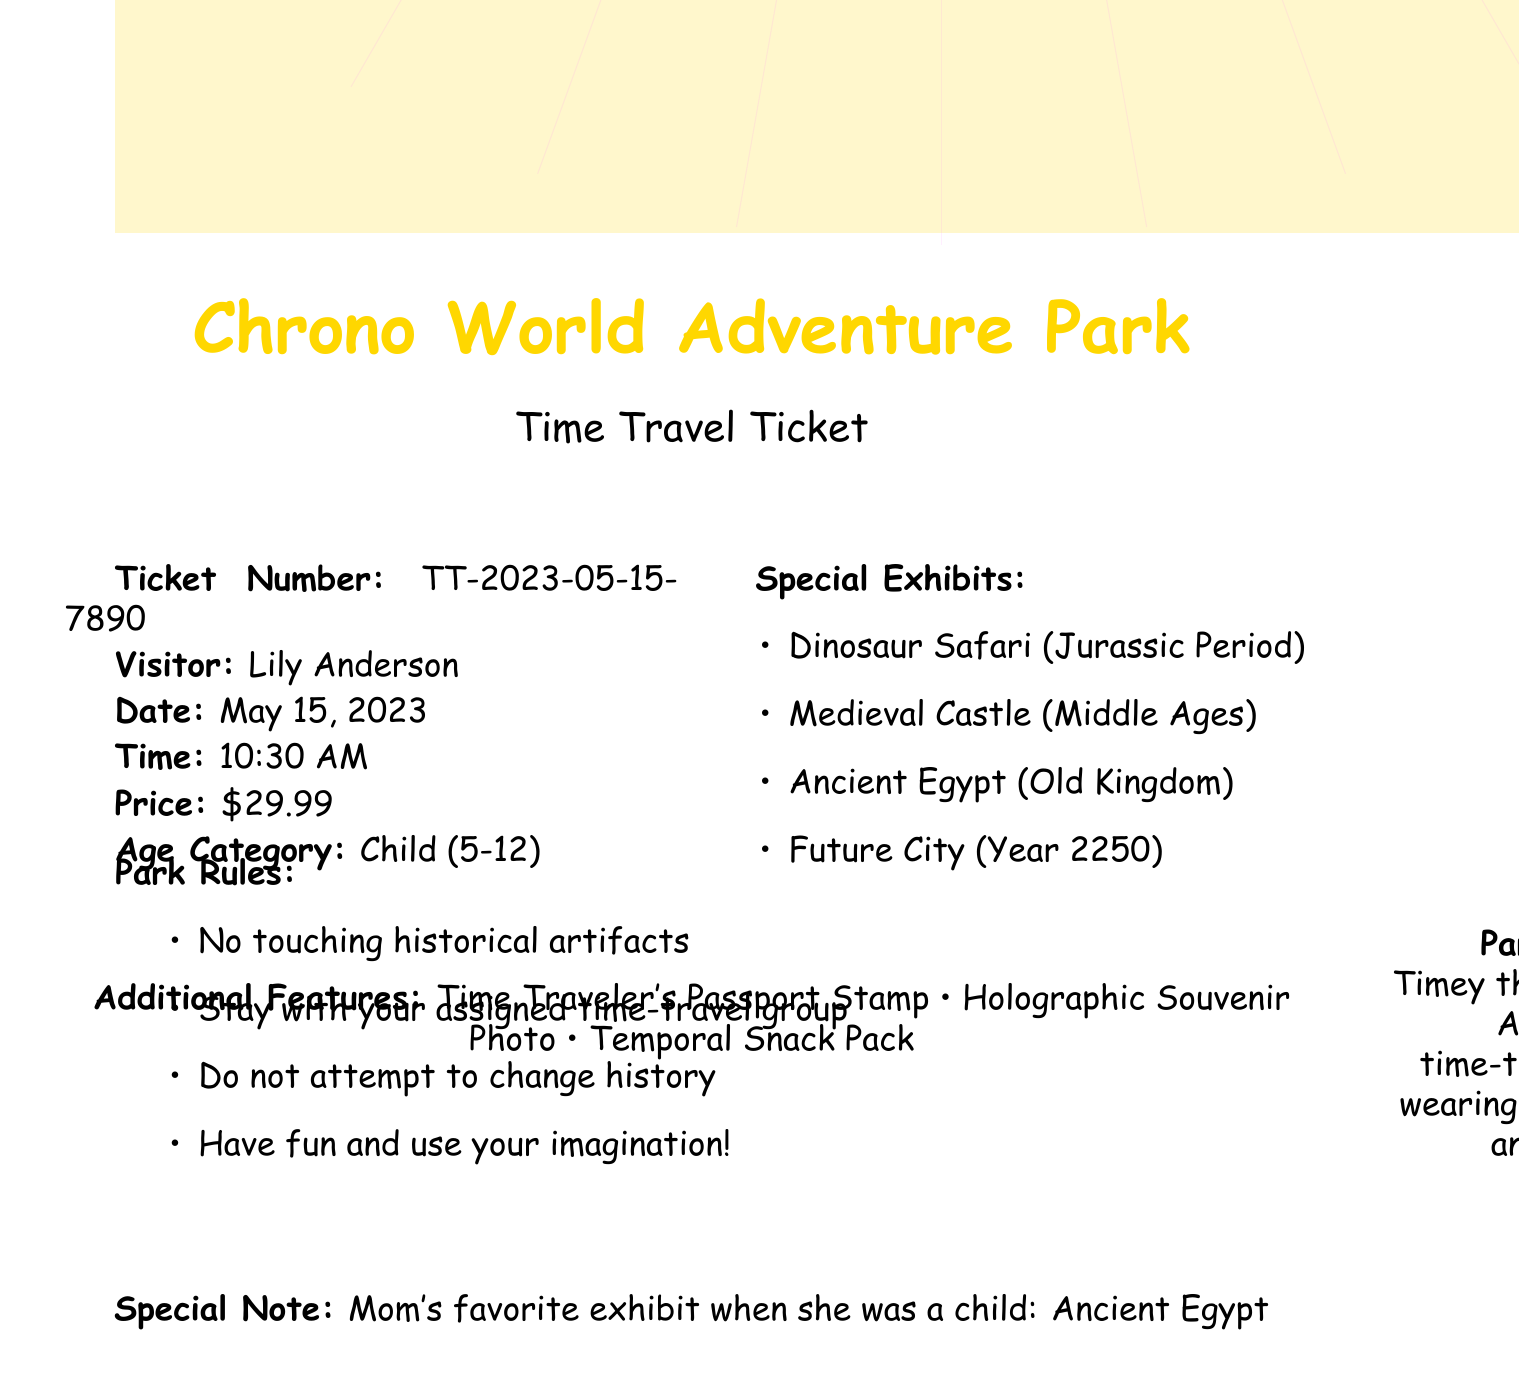What is the name of the park? The park name is provided at the beginning of the document.
Answer: Chrono World Adventure Park What is the ticket number? The ticket number is mentioned under the ticket details section of the document.
Answer: TT-2023-05-15-7890 What is the admission price? The price is listed clearly in the ticket details section.
Answer: $29.99 Who is the visitor? The visitor's name is specified in the ticket details.
Answer: Lily Anderson Which special exhibit was Mom's favorite when she was a child? This information can be found in the special note at the bottom of the document.
Answer: Ancient Egypt What age category does this ticket apply to? The age category is listed within the ticket details section.
Answer: Child (5-12) What can you do in the Future City exhibit? This requires reasoning about the description provided for the exhibit.
Answer: Experience life in a futuristic metropolis with flying cars and robot assistants! What are the park rules? The rules are outlined clearly in the document; the question asks for detail from that section.
Answer: No touching historical artifacts, Stay with your assigned time-travel group, Do not attempt to change history, Have fun and use your imagination! What is the park mascot's name? The name of the park mascot is provided in the park mascot section.
Answer: Timey the Tardis Turtle What is included in the additional features? The document lists a variety of features included with the ticket.
Answer: Time Traveler's Passport Stamp, Holographic Souvenir Photo, Temporal Snack Pack 